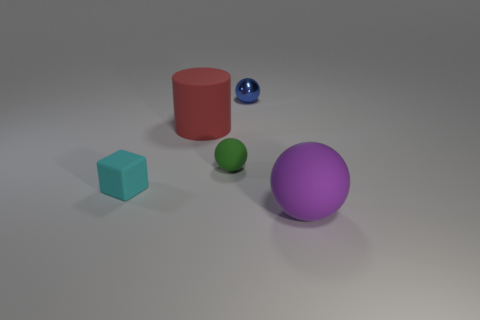There is another purple thing that is the same shape as the shiny object; what is its size?
Provide a succinct answer. Large. There is a sphere right of the shiny ball; is its size the same as the cylinder?
Give a very brief answer. Yes. There is a object that is to the left of the green ball and behind the cyan matte block; how big is it?
Offer a terse response. Large. What number of balls have the same color as the big cylinder?
Offer a terse response. 0. Are there an equal number of blue spheres in front of the green thing and big blue rubber cubes?
Provide a short and direct response. Yes. What color is the big sphere?
Ensure brevity in your answer.  Purple. What size is the other sphere that is made of the same material as the large purple sphere?
Offer a very short reply. Small. There is a large cylinder that is the same material as the cyan cube; what color is it?
Your response must be concise. Red. Is there a thing that has the same size as the cylinder?
Your response must be concise. Yes. There is a blue thing that is the same shape as the green object; what is its material?
Provide a succinct answer. Metal. 